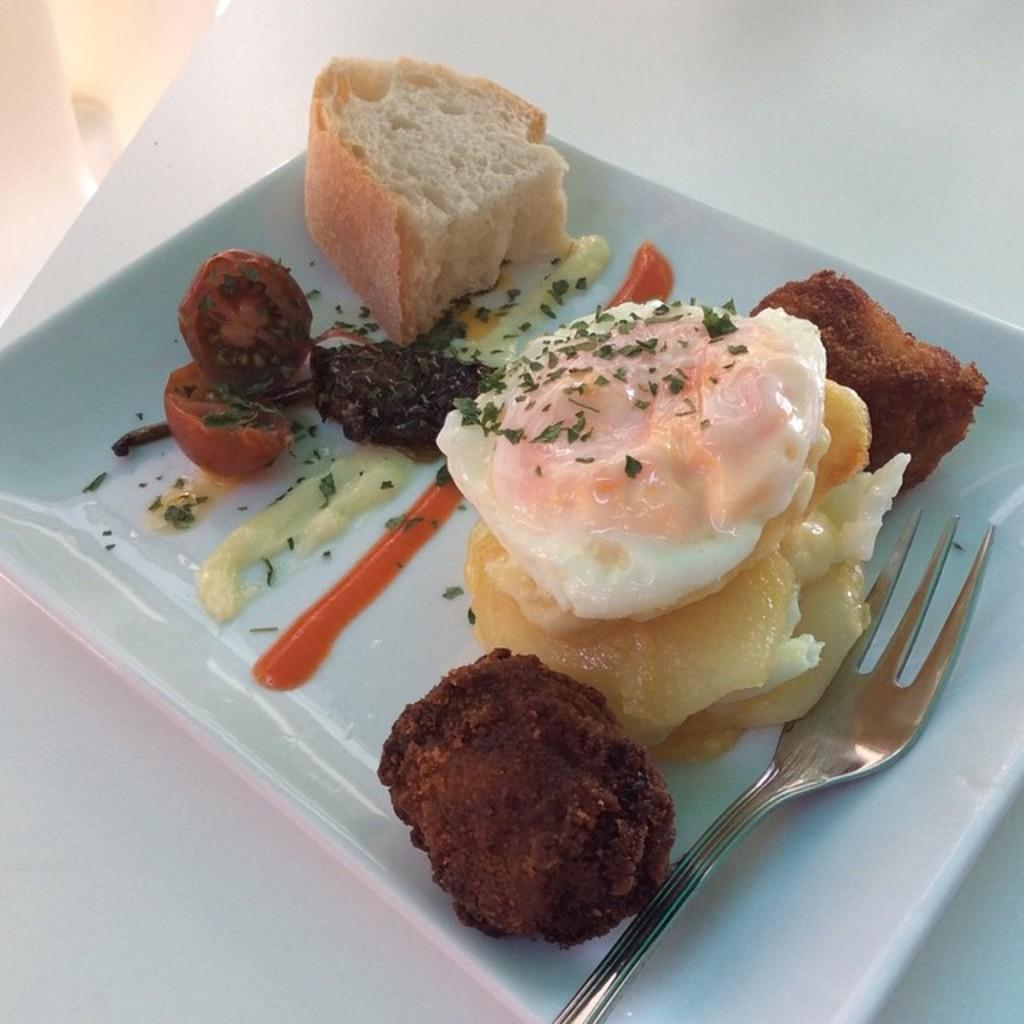What is on the plate in the image? There are food items on a plate in the image. What color is the plate? The plate is white in color. What utensil is visible in the image? There is a fork in the image. What type of shoe can be seen in the image? There is no shoe present in the image; it features a plate with food items and a fork. How many threads are visible in the image? There are no threads visible in the image. 